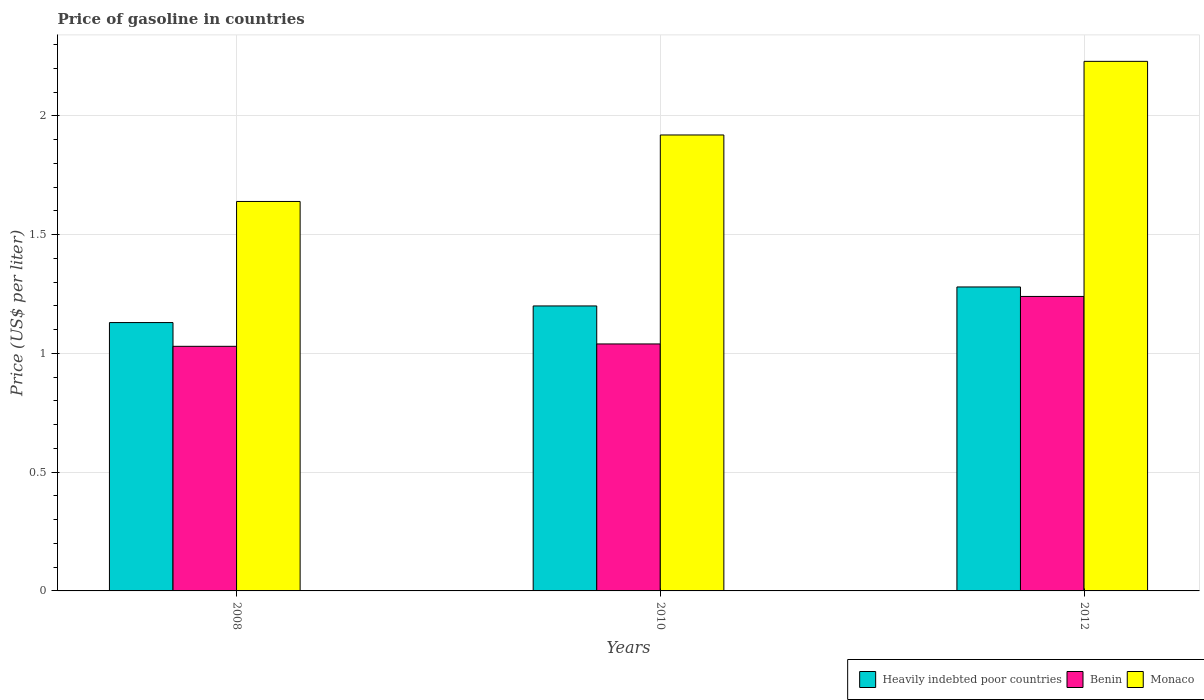Are the number of bars per tick equal to the number of legend labels?
Provide a short and direct response. Yes. How many bars are there on the 3rd tick from the left?
Provide a succinct answer. 3. What is the label of the 2nd group of bars from the left?
Offer a terse response. 2010. In how many cases, is the number of bars for a given year not equal to the number of legend labels?
Ensure brevity in your answer.  0. Across all years, what is the maximum price of gasoline in Monaco?
Provide a succinct answer. 2.23. Across all years, what is the minimum price of gasoline in Benin?
Your answer should be compact. 1.03. In which year was the price of gasoline in Monaco minimum?
Your response must be concise. 2008. What is the total price of gasoline in Benin in the graph?
Your response must be concise. 3.31. What is the difference between the price of gasoline in Benin in 2008 and that in 2010?
Make the answer very short. -0.01. What is the difference between the price of gasoline in Benin in 2010 and the price of gasoline in Heavily indebted poor countries in 2012?
Your answer should be compact. -0.24. What is the average price of gasoline in Benin per year?
Your answer should be very brief. 1.1. In the year 2012, what is the difference between the price of gasoline in Benin and price of gasoline in Heavily indebted poor countries?
Provide a short and direct response. -0.04. In how many years, is the price of gasoline in Monaco greater than 1.8 US$?
Keep it short and to the point. 2. Is the price of gasoline in Heavily indebted poor countries in 2008 less than that in 2012?
Offer a terse response. Yes. Is the difference between the price of gasoline in Benin in 2008 and 2012 greater than the difference between the price of gasoline in Heavily indebted poor countries in 2008 and 2012?
Offer a very short reply. No. What is the difference between the highest and the second highest price of gasoline in Heavily indebted poor countries?
Your response must be concise. 0.08. What is the difference between the highest and the lowest price of gasoline in Heavily indebted poor countries?
Give a very brief answer. 0.15. Is the sum of the price of gasoline in Benin in 2008 and 2012 greater than the maximum price of gasoline in Monaco across all years?
Provide a succinct answer. Yes. What does the 3rd bar from the left in 2008 represents?
Give a very brief answer. Monaco. What does the 2nd bar from the right in 2012 represents?
Your answer should be compact. Benin. How many bars are there?
Your response must be concise. 9. Are all the bars in the graph horizontal?
Provide a short and direct response. No. Where does the legend appear in the graph?
Keep it short and to the point. Bottom right. How many legend labels are there?
Your response must be concise. 3. What is the title of the graph?
Your answer should be very brief. Price of gasoline in countries. What is the label or title of the X-axis?
Your answer should be very brief. Years. What is the label or title of the Y-axis?
Provide a short and direct response. Price (US$ per liter). What is the Price (US$ per liter) of Heavily indebted poor countries in 2008?
Make the answer very short. 1.13. What is the Price (US$ per liter) of Benin in 2008?
Provide a succinct answer. 1.03. What is the Price (US$ per liter) in Monaco in 2008?
Provide a succinct answer. 1.64. What is the Price (US$ per liter) of Monaco in 2010?
Your answer should be very brief. 1.92. What is the Price (US$ per liter) in Heavily indebted poor countries in 2012?
Your answer should be very brief. 1.28. What is the Price (US$ per liter) in Benin in 2012?
Your answer should be compact. 1.24. What is the Price (US$ per liter) of Monaco in 2012?
Ensure brevity in your answer.  2.23. Across all years, what is the maximum Price (US$ per liter) of Heavily indebted poor countries?
Provide a succinct answer. 1.28. Across all years, what is the maximum Price (US$ per liter) in Benin?
Keep it short and to the point. 1.24. Across all years, what is the maximum Price (US$ per liter) of Monaco?
Make the answer very short. 2.23. Across all years, what is the minimum Price (US$ per liter) of Heavily indebted poor countries?
Your answer should be very brief. 1.13. Across all years, what is the minimum Price (US$ per liter) of Monaco?
Give a very brief answer. 1.64. What is the total Price (US$ per liter) of Heavily indebted poor countries in the graph?
Provide a succinct answer. 3.61. What is the total Price (US$ per liter) in Benin in the graph?
Keep it short and to the point. 3.31. What is the total Price (US$ per liter) in Monaco in the graph?
Your answer should be compact. 5.79. What is the difference between the Price (US$ per liter) in Heavily indebted poor countries in 2008 and that in 2010?
Your answer should be compact. -0.07. What is the difference between the Price (US$ per liter) in Benin in 2008 and that in 2010?
Provide a succinct answer. -0.01. What is the difference between the Price (US$ per liter) in Monaco in 2008 and that in 2010?
Offer a terse response. -0.28. What is the difference between the Price (US$ per liter) in Benin in 2008 and that in 2012?
Your response must be concise. -0.21. What is the difference between the Price (US$ per liter) of Monaco in 2008 and that in 2012?
Keep it short and to the point. -0.59. What is the difference between the Price (US$ per liter) in Heavily indebted poor countries in 2010 and that in 2012?
Provide a succinct answer. -0.08. What is the difference between the Price (US$ per liter) in Benin in 2010 and that in 2012?
Your answer should be compact. -0.2. What is the difference between the Price (US$ per liter) of Monaco in 2010 and that in 2012?
Your answer should be compact. -0.31. What is the difference between the Price (US$ per liter) of Heavily indebted poor countries in 2008 and the Price (US$ per liter) of Benin in 2010?
Offer a very short reply. 0.09. What is the difference between the Price (US$ per liter) in Heavily indebted poor countries in 2008 and the Price (US$ per liter) in Monaco in 2010?
Provide a short and direct response. -0.79. What is the difference between the Price (US$ per liter) of Benin in 2008 and the Price (US$ per liter) of Monaco in 2010?
Your response must be concise. -0.89. What is the difference between the Price (US$ per liter) in Heavily indebted poor countries in 2008 and the Price (US$ per liter) in Benin in 2012?
Provide a succinct answer. -0.11. What is the difference between the Price (US$ per liter) of Heavily indebted poor countries in 2008 and the Price (US$ per liter) of Monaco in 2012?
Your answer should be compact. -1.1. What is the difference between the Price (US$ per liter) of Benin in 2008 and the Price (US$ per liter) of Monaco in 2012?
Offer a terse response. -1.2. What is the difference between the Price (US$ per liter) of Heavily indebted poor countries in 2010 and the Price (US$ per liter) of Benin in 2012?
Provide a short and direct response. -0.04. What is the difference between the Price (US$ per liter) of Heavily indebted poor countries in 2010 and the Price (US$ per liter) of Monaco in 2012?
Your response must be concise. -1.03. What is the difference between the Price (US$ per liter) of Benin in 2010 and the Price (US$ per liter) of Monaco in 2012?
Give a very brief answer. -1.19. What is the average Price (US$ per liter) of Heavily indebted poor countries per year?
Give a very brief answer. 1.2. What is the average Price (US$ per liter) in Benin per year?
Ensure brevity in your answer.  1.1. What is the average Price (US$ per liter) of Monaco per year?
Make the answer very short. 1.93. In the year 2008, what is the difference between the Price (US$ per liter) in Heavily indebted poor countries and Price (US$ per liter) in Benin?
Give a very brief answer. 0.1. In the year 2008, what is the difference between the Price (US$ per liter) of Heavily indebted poor countries and Price (US$ per liter) of Monaco?
Your answer should be compact. -0.51. In the year 2008, what is the difference between the Price (US$ per liter) in Benin and Price (US$ per liter) in Monaco?
Make the answer very short. -0.61. In the year 2010, what is the difference between the Price (US$ per liter) of Heavily indebted poor countries and Price (US$ per liter) of Benin?
Your answer should be very brief. 0.16. In the year 2010, what is the difference between the Price (US$ per liter) of Heavily indebted poor countries and Price (US$ per liter) of Monaco?
Make the answer very short. -0.72. In the year 2010, what is the difference between the Price (US$ per liter) of Benin and Price (US$ per liter) of Monaco?
Your answer should be very brief. -0.88. In the year 2012, what is the difference between the Price (US$ per liter) in Heavily indebted poor countries and Price (US$ per liter) in Benin?
Your response must be concise. 0.04. In the year 2012, what is the difference between the Price (US$ per liter) in Heavily indebted poor countries and Price (US$ per liter) in Monaco?
Your response must be concise. -0.95. In the year 2012, what is the difference between the Price (US$ per liter) in Benin and Price (US$ per liter) in Monaco?
Make the answer very short. -0.99. What is the ratio of the Price (US$ per liter) in Heavily indebted poor countries in 2008 to that in 2010?
Offer a very short reply. 0.94. What is the ratio of the Price (US$ per liter) of Monaco in 2008 to that in 2010?
Ensure brevity in your answer.  0.85. What is the ratio of the Price (US$ per liter) of Heavily indebted poor countries in 2008 to that in 2012?
Give a very brief answer. 0.88. What is the ratio of the Price (US$ per liter) in Benin in 2008 to that in 2012?
Your answer should be very brief. 0.83. What is the ratio of the Price (US$ per liter) in Monaco in 2008 to that in 2012?
Offer a very short reply. 0.74. What is the ratio of the Price (US$ per liter) of Benin in 2010 to that in 2012?
Provide a succinct answer. 0.84. What is the ratio of the Price (US$ per liter) in Monaco in 2010 to that in 2012?
Provide a short and direct response. 0.86. What is the difference between the highest and the second highest Price (US$ per liter) in Benin?
Your answer should be compact. 0.2. What is the difference between the highest and the second highest Price (US$ per liter) of Monaco?
Your answer should be very brief. 0.31. What is the difference between the highest and the lowest Price (US$ per liter) of Heavily indebted poor countries?
Make the answer very short. 0.15. What is the difference between the highest and the lowest Price (US$ per liter) in Benin?
Ensure brevity in your answer.  0.21. What is the difference between the highest and the lowest Price (US$ per liter) of Monaco?
Keep it short and to the point. 0.59. 